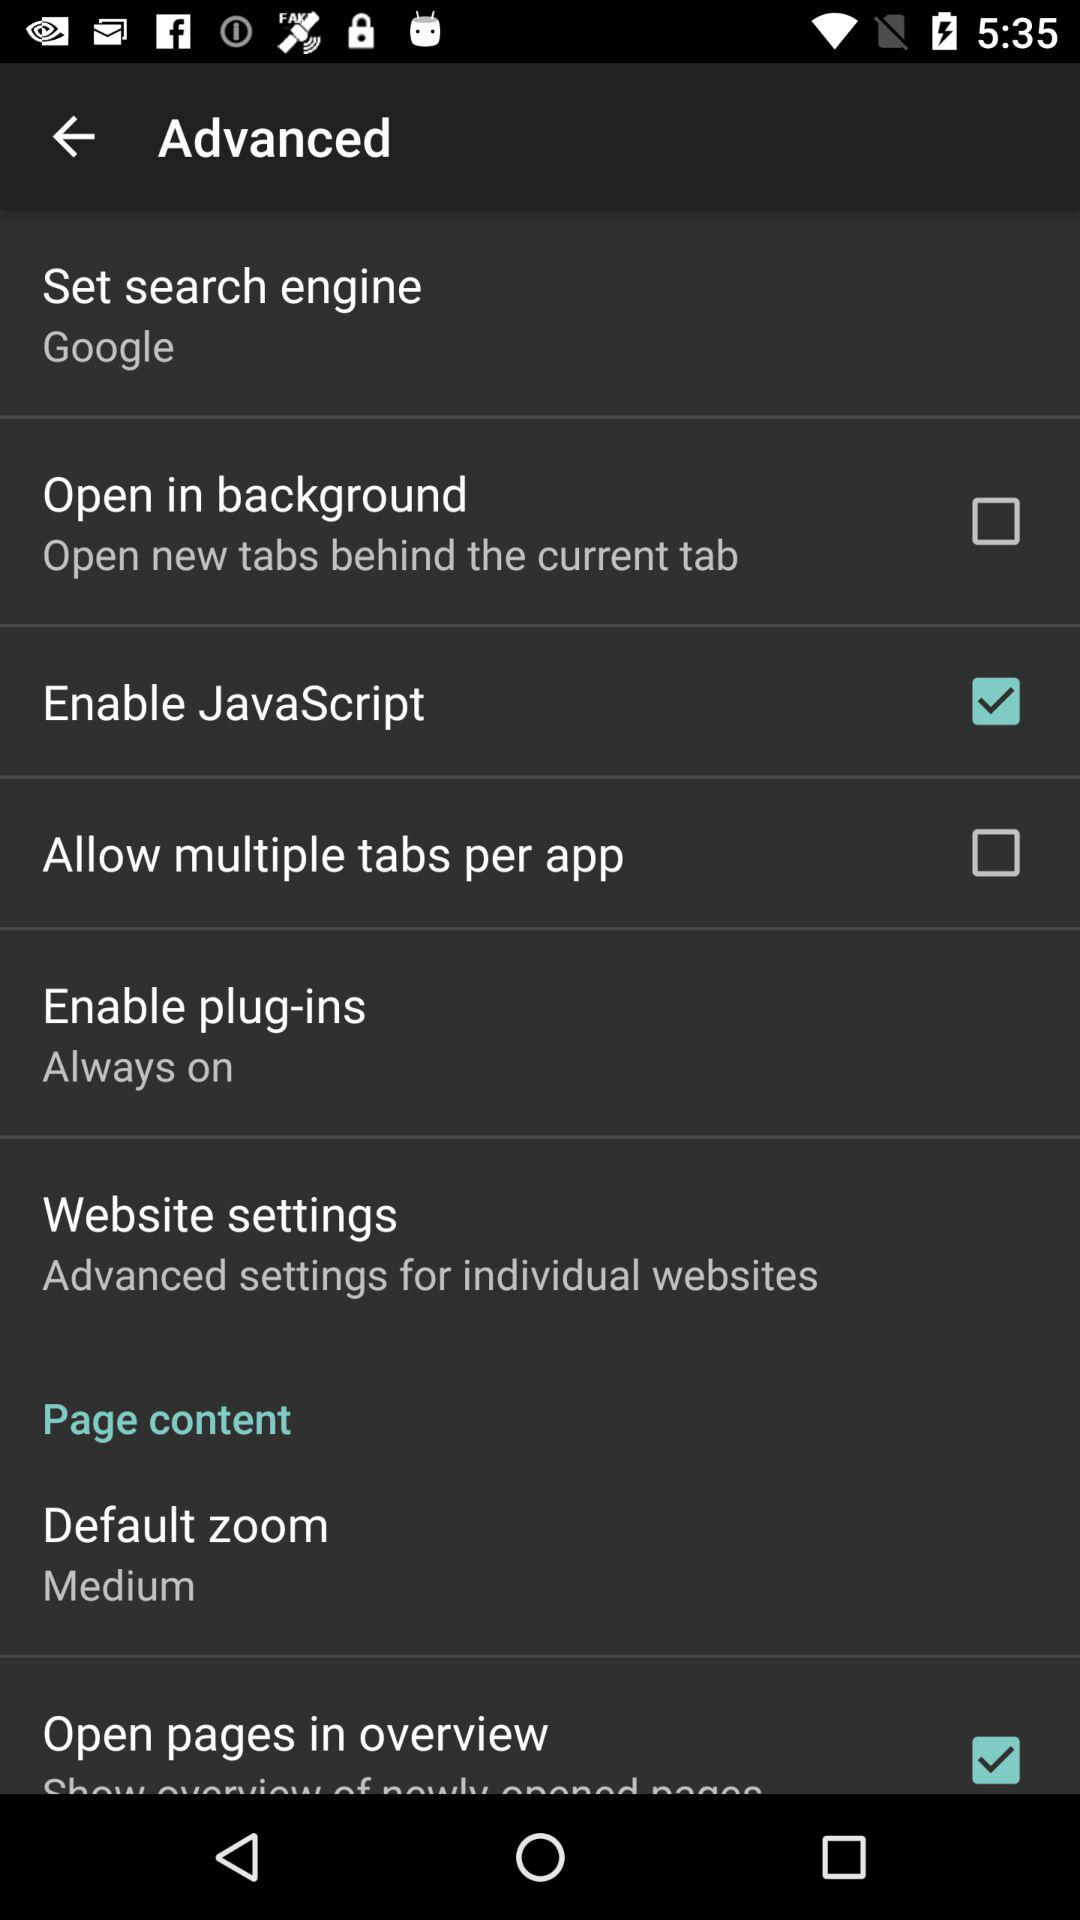What is the status of "Enable JavaScript"? The status is "on". 